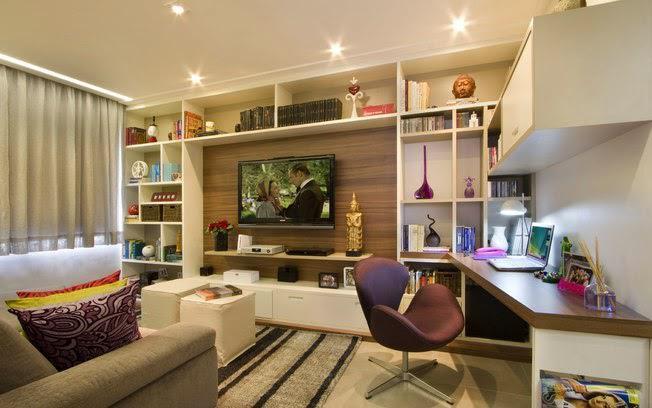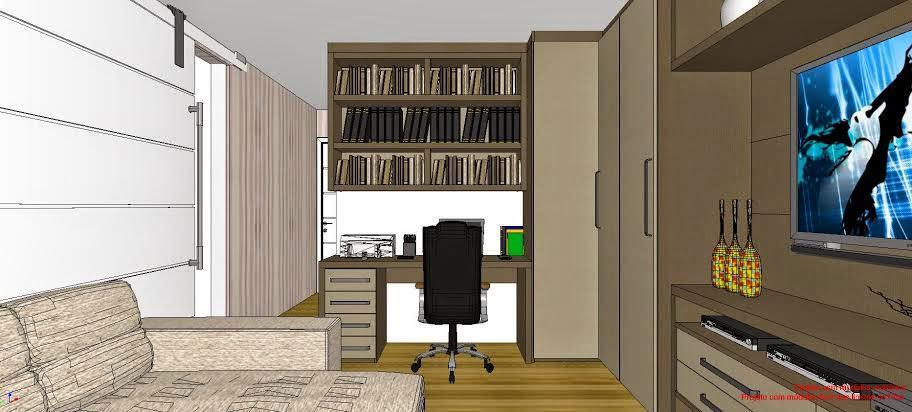The first image is the image on the left, the second image is the image on the right. Given the left and right images, does the statement "Curtains cover a window in the image on the left." hold true? Answer yes or no. Yes. The first image is the image on the left, the second image is the image on the right. Evaluate the accuracy of this statement regarding the images: "There is at least one light dangling from the ceiling.". Is it true? Answer yes or no. No. 